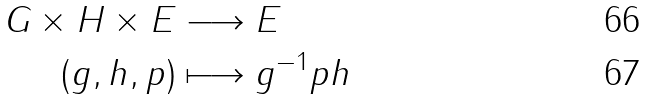<formula> <loc_0><loc_0><loc_500><loc_500>G \times H \times E & \longrightarrow E \\ ( g , h , p ) & \longmapsto g ^ { - 1 } p h</formula> 